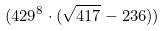Convert formula to latex. <formula><loc_0><loc_0><loc_500><loc_500>( 4 2 9 ^ { 8 } \cdot ( \sqrt { 4 1 7 } - 2 3 6 ) )</formula> 